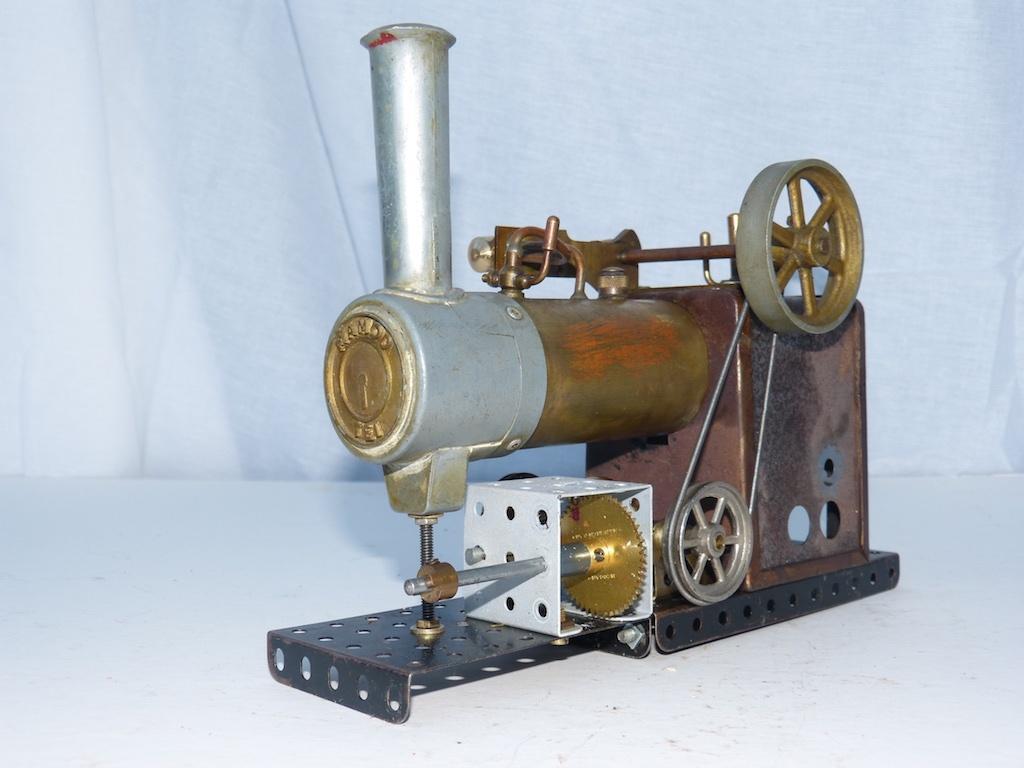Can you describe this image briefly? In this image there is a machine. 